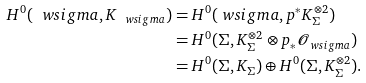<formula> <loc_0><loc_0><loc_500><loc_500>H ^ { 0 } ( \ w s i g m a , K _ { \ w s i g m a } ) & = H ^ { 0 } ( \ w s i g m a , p ^ { * } K _ { \Sigma } ^ { \otimes 2 } ) \\ & = H ^ { 0 } ( \Sigma , K _ { \Sigma } ^ { \otimes 2 } \otimes p _ { * } { \mathcal { O } } _ { \ w s i g m a } ) \\ & = H ^ { 0 } ( \Sigma , K _ { \Sigma } ) \oplus H ^ { 0 } ( \Sigma , K _ { \Sigma } ^ { \otimes 2 } ) .</formula> 